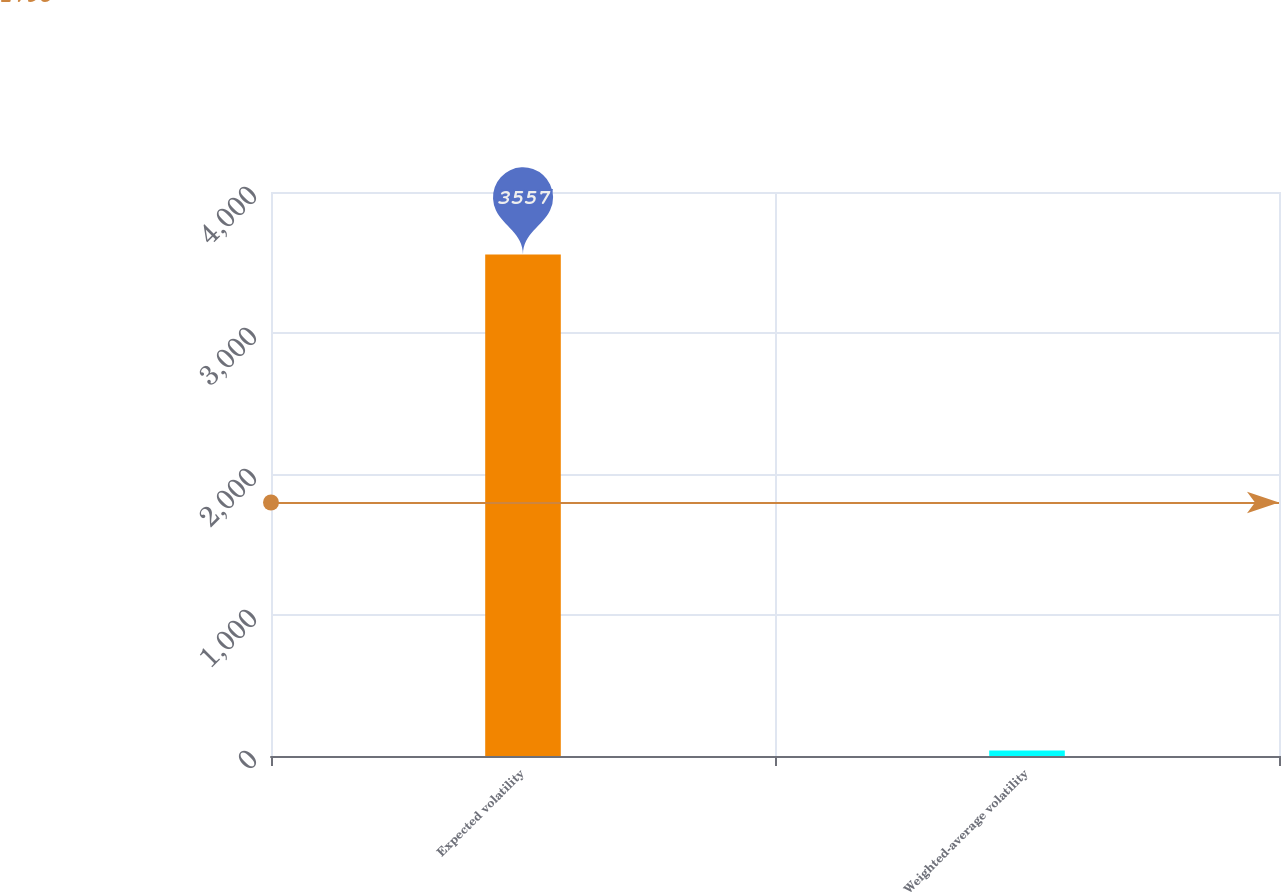Convert chart to OTSL. <chart><loc_0><loc_0><loc_500><loc_500><bar_chart><fcel>Expected volatility<fcel>Weighted-average volatility<nl><fcel>3557<fcel>39<nl></chart> 